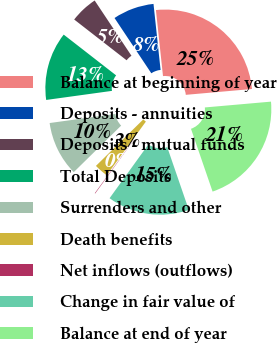Convert chart to OTSL. <chart><loc_0><loc_0><loc_500><loc_500><pie_chart><fcel>Balance at beginning of year<fcel>Deposits - annuities<fcel>Deposits - mutual funds<fcel>Total Deposits<fcel>Surrenders and other<fcel>Death benefits<fcel>Net inflows (outflows)<fcel>Change in fair value of<fcel>Balance at end of year<nl><fcel>25.3%<fcel>7.65%<fcel>5.13%<fcel>12.7%<fcel>10.17%<fcel>2.61%<fcel>0.09%<fcel>15.22%<fcel>21.12%<nl></chart> 